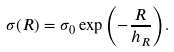Convert formula to latex. <formula><loc_0><loc_0><loc_500><loc_500>\sigma ( R ) = \sigma _ { 0 } \exp { \left ( - \frac { R } { h _ { R } } \right ) } .</formula> 